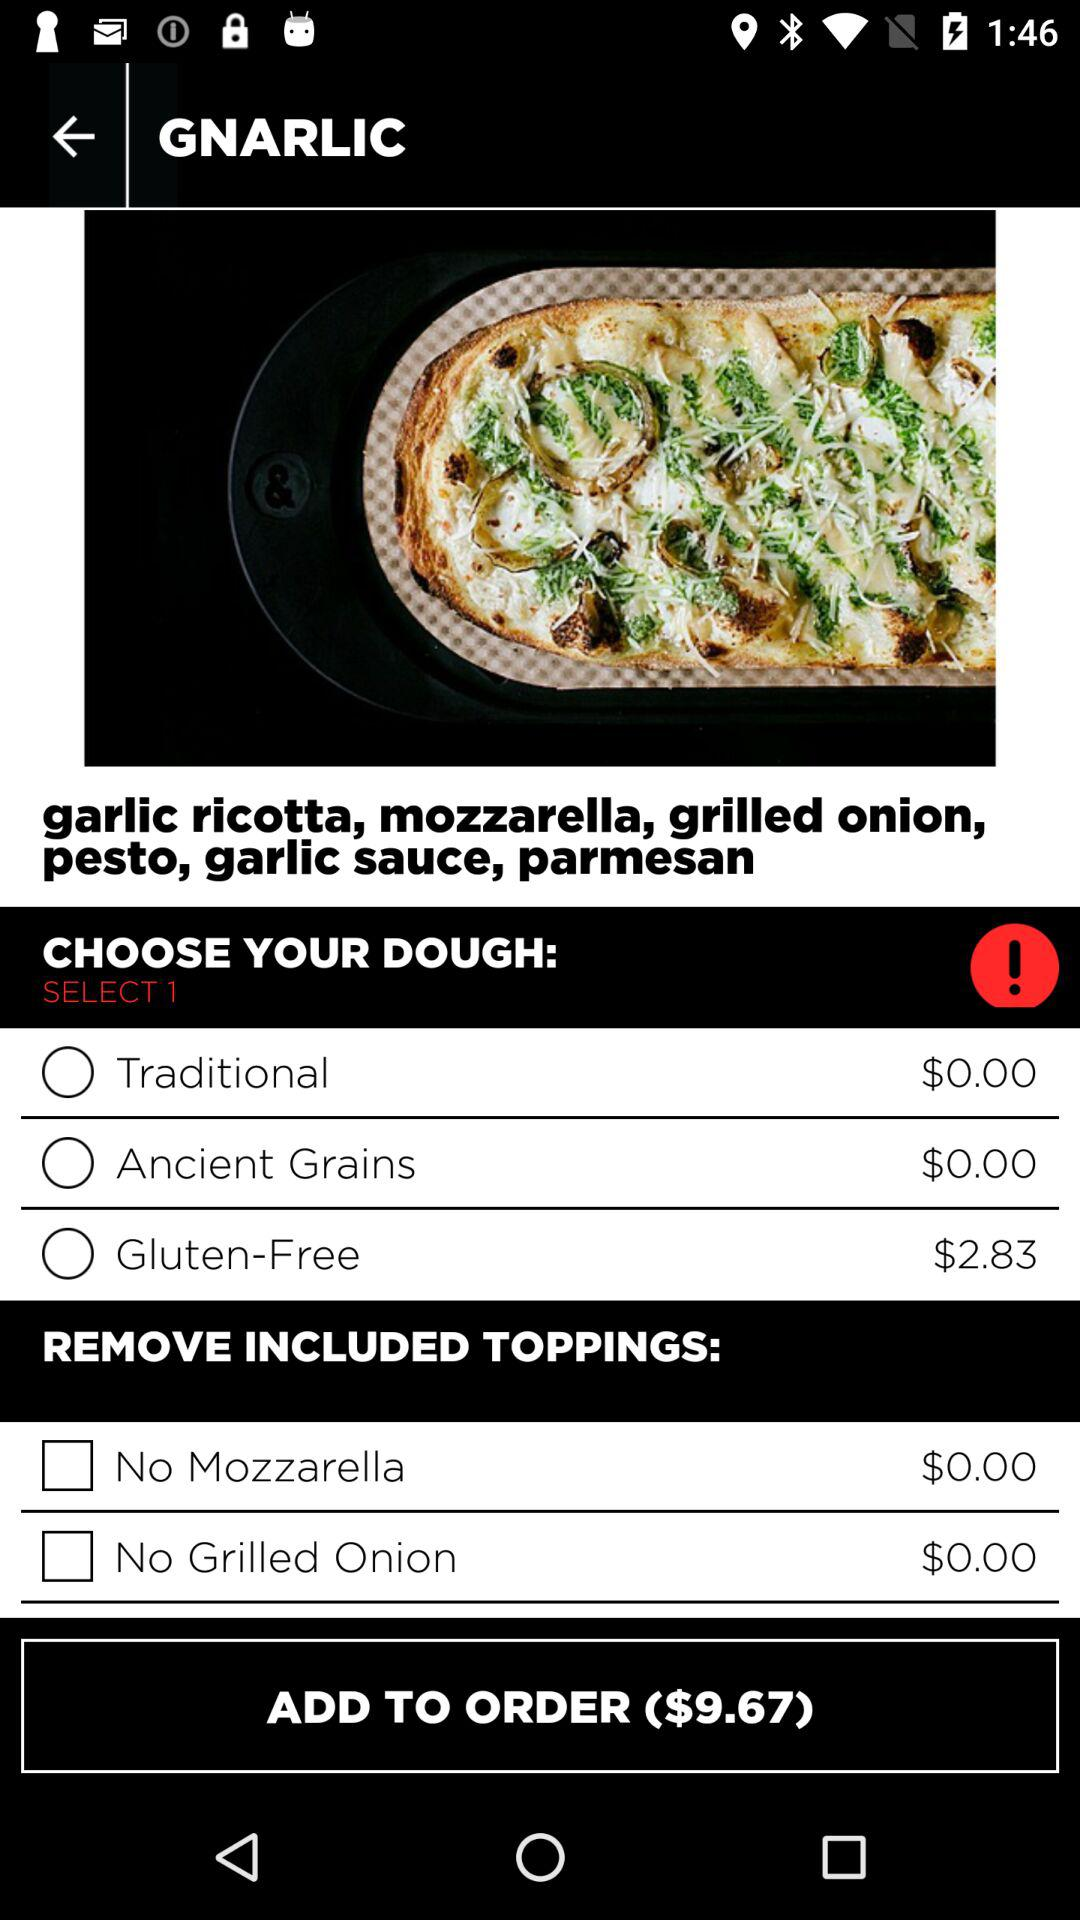What is the currency of prices? The currency of prices is dollars. 